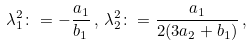<formula> <loc_0><loc_0><loc_500><loc_500>\lambda _ { 1 } ^ { 2 } \colon = - \frac { a _ { 1 } } { b _ { 1 } } \, , \, \lambda _ { 2 } ^ { 2 } \colon = \frac { a _ { 1 } } { 2 ( 3 a _ { 2 } + b _ { 1 } ) } \, ,</formula> 